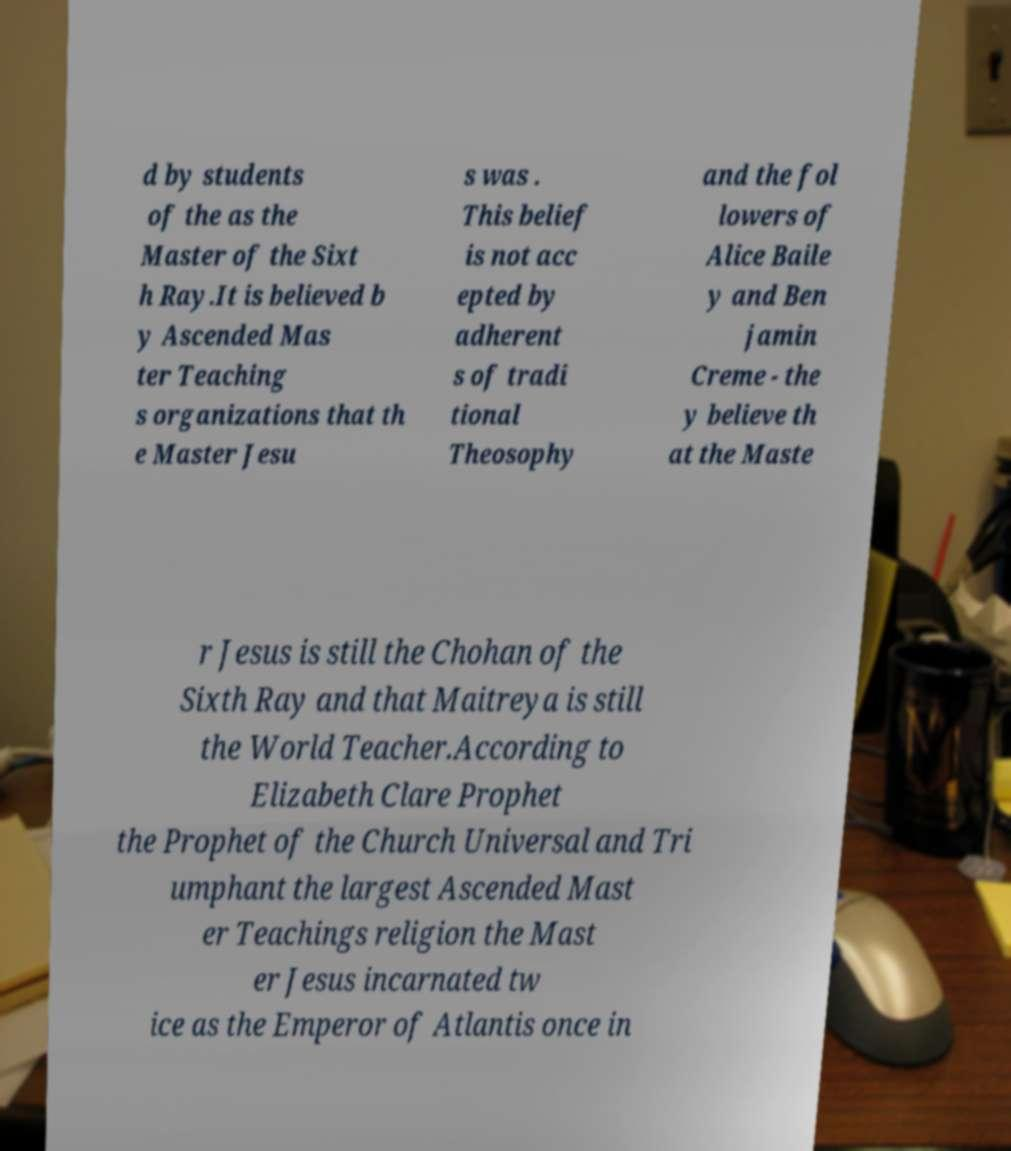There's text embedded in this image that I need extracted. Can you transcribe it verbatim? d by students of the as the Master of the Sixt h Ray.It is believed b y Ascended Mas ter Teaching s organizations that th e Master Jesu s was . This belief is not acc epted by adherent s of tradi tional Theosophy and the fol lowers of Alice Baile y and Ben jamin Creme - the y believe th at the Maste r Jesus is still the Chohan of the Sixth Ray and that Maitreya is still the World Teacher.According to Elizabeth Clare Prophet the Prophet of the Church Universal and Tri umphant the largest Ascended Mast er Teachings religion the Mast er Jesus incarnated tw ice as the Emperor of Atlantis once in 